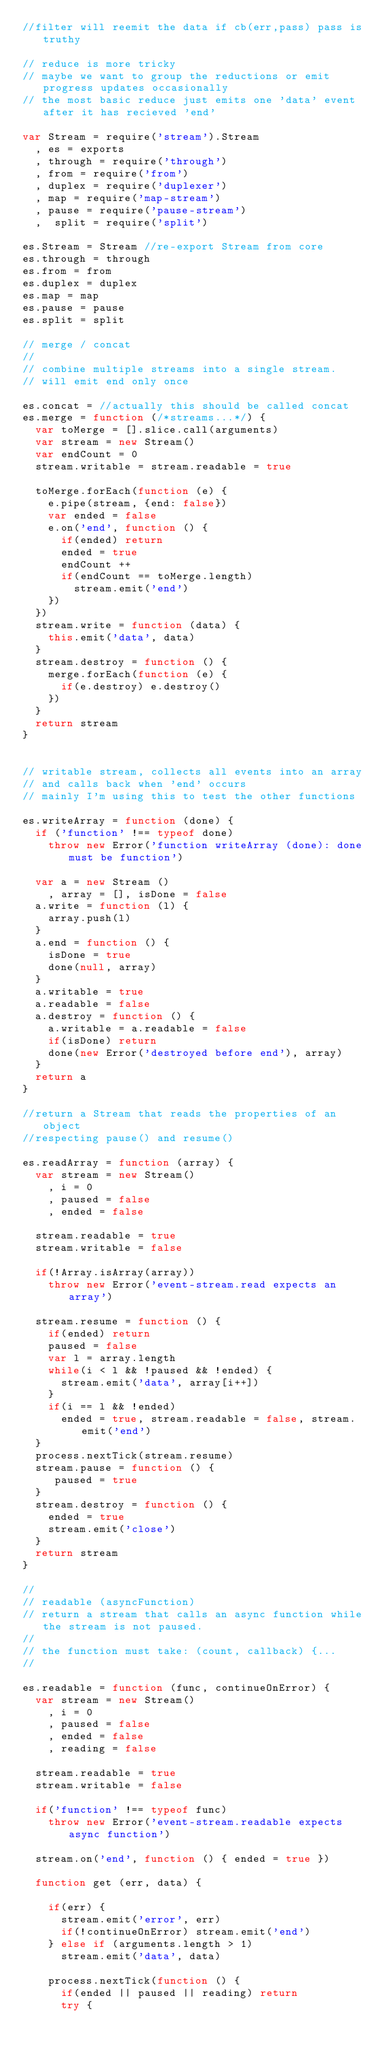<code> <loc_0><loc_0><loc_500><loc_500><_JavaScript_>//filter will reemit the data if cb(err,pass) pass is truthy

// reduce is more tricky
// maybe we want to group the reductions or emit progress updates occasionally
// the most basic reduce just emits one 'data' event after it has recieved 'end'

var Stream = require('stream').Stream
  , es = exports
  , through = require('through')
  , from = require('from')
  , duplex = require('duplexer')
  , map = require('map-stream')
  , pause = require('pause-stream')
  ,  split = require('split')

es.Stream = Stream //re-export Stream from core
es.through = through
es.from = from
es.duplex = duplex
es.map = map
es.pause = pause
es.split = split

// merge / concat
//
// combine multiple streams into a single stream.
// will emit end only once

es.concat = //actually this should be called concat
es.merge = function (/*streams...*/) {
  var toMerge = [].slice.call(arguments)
  var stream = new Stream()
  var endCount = 0
  stream.writable = stream.readable = true

  toMerge.forEach(function (e) {
    e.pipe(stream, {end: false})
    var ended = false
    e.on('end', function () {
      if(ended) return
      ended = true
      endCount ++
      if(endCount == toMerge.length)
        stream.emit('end') 
    })
  })
  stream.write = function (data) {
    this.emit('data', data)
  }
  stream.destroy = function () {
    merge.forEach(function (e) {
      if(e.destroy) e.destroy()
    })
  }
  return stream
}


// writable stream, collects all events into an array 
// and calls back when 'end' occurs
// mainly I'm using this to test the other functions

es.writeArray = function (done) {
  if ('function' !== typeof done)
    throw new Error('function writeArray (done): done must be function')

  var a = new Stream ()
    , array = [], isDone = false
  a.write = function (l) {
    array.push(l)
  }
  a.end = function () {
    isDone = true
    done(null, array)
  }
  a.writable = true
  a.readable = false
  a.destroy = function () {
    a.writable = a.readable = false
    if(isDone) return
    done(new Error('destroyed before end'), array)
  }
  return a
}

//return a Stream that reads the properties of an object
//respecting pause() and resume()

es.readArray = function (array) {
  var stream = new Stream()
    , i = 0
    , paused = false
    , ended = false
 
  stream.readable = true  
  stream.writable = false
 
  if(!Array.isArray(array))
    throw new Error('event-stream.read expects an array')
  
  stream.resume = function () {
    if(ended) return
    paused = false
    var l = array.length
    while(i < l && !paused && !ended) {
      stream.emit('data', array[i++])
    }
    if(i == l && !ended)
      ended = true, stream.readable = false, stream.emit('end')
  }
  process.nextTick(stream.resume)
  stream.pause = function () {
     paused = true
  }
  stream.destroy = function () {
    ended = true
    stream.emit('close')
  }
  return stream
}

//
// readable (asyncFunction)
// return a stream that calls an async function while the stream is not paused.
//
// the function must take: (count, callback) {...
//

es.readable = function (func, continueOnError) {
  var stream = new Stream()
    , i = 0
    , paused = false
    , ended = false
    , reading = false

  stream.readable = true  
  stream.writable = false
 
  if('function' !== typeof func)
    throw new Error('event-stream.readable expects async function')
  
  stream.on('end', function () { ended = true })
  
  function get (err, data) {
    
    if(err) {
      stream.emit('error', err)
      if(!continueOnError) stream.emit('end')
    } else if (arguments.length > 1)
      stream.emit('data', data)

    process.nextTick(function () {
      if(ended || paused || reading) return
      try {</code> 